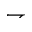<formula> <loc_0><loc_0><loc_500><loc_500>\rightharpoondown</formula> 